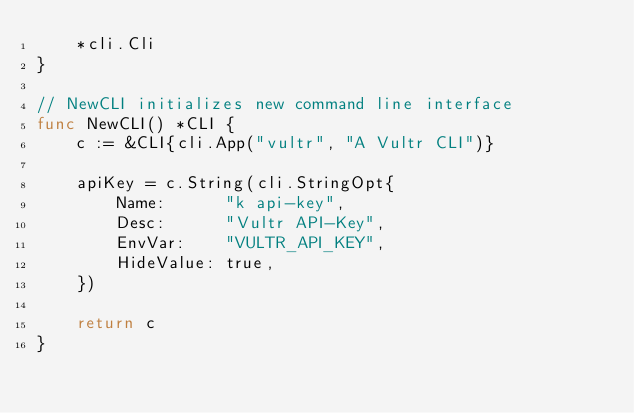Convert code to text. <code><loc_0><loc_0><loc_500><loc_500><_Go_>	*cli.Cli
}

// NewCLI initializes new command line interface
func NewCLI() *CLI {
	c := &CLI{cli.App("vultr", "A Vultr CLI")}

	apiKey = c.String(cli.StringOpt{
		Name:      "k api-key",
		Desc:      "Vultr API-Key",
		EnvVar:    "VULTR_API_KEY",
		HideValue: true,
	})

	return c
}
</code> 